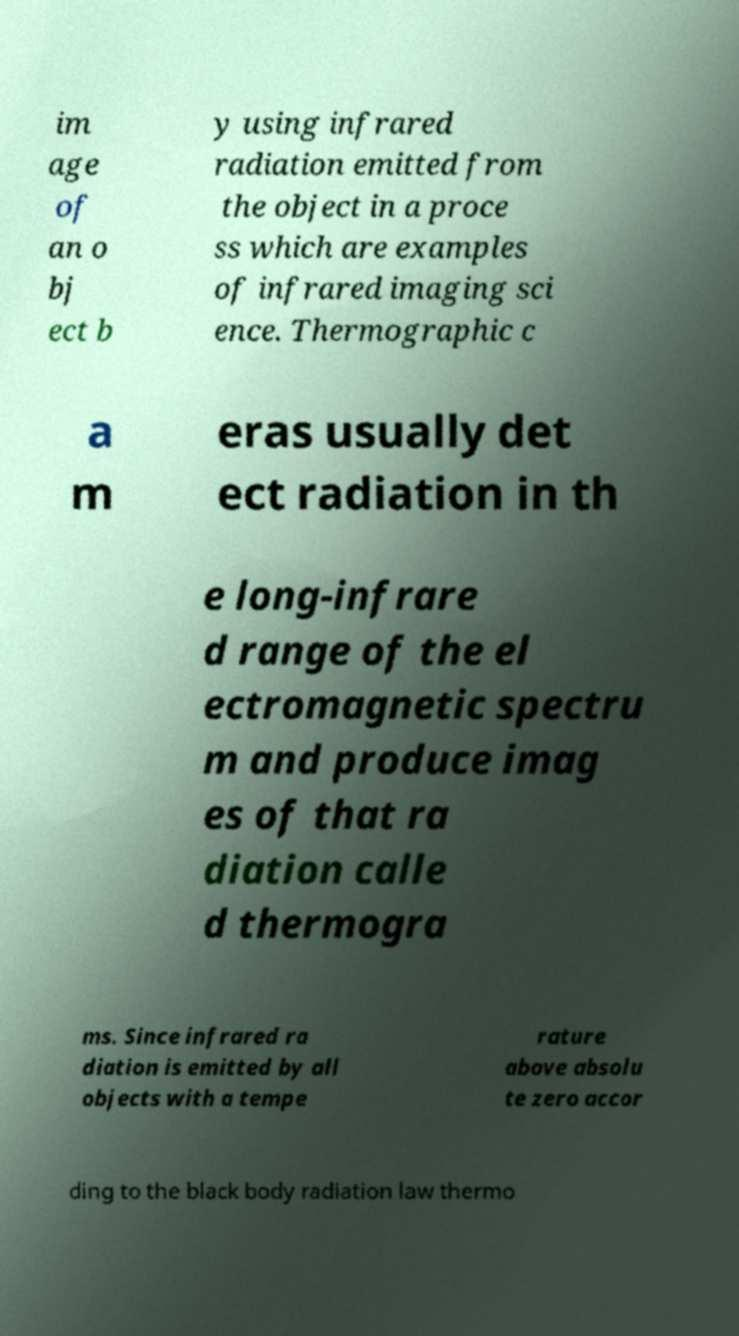Can you read and provide the text displayed in the image?This photo seems to have some interesting text. Can you extract and type it out for me? im age of an o bj ect b y using infrared radiation emitted from the object in a proce ss which are examples of infrared imaging sci ence. Thermographic c a m eras usually det ect radiation in th e long-infrare d range of the el ectromagnetic spectru m and produce imag es of that ra diation calle d thermogra ms. Since infrared ra diation is emitted by all objects with a tempe rature above absolu te zero accor ding to the black body radiation law thermo 